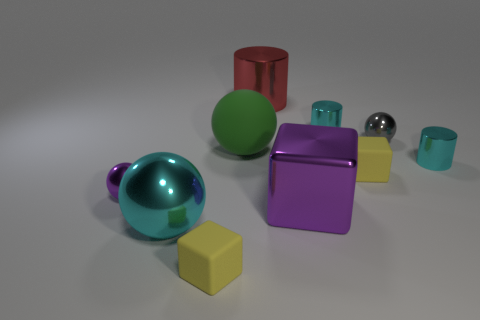Subtract 2 spheres. How many spheres are left? 2 Subtract all blue spheres. Subtract all blue cylinders. How many spheres are left? 4 Subtract all cylinders. How many objects are left? 7 Subtract 0 brown blocks. How many objects are left? 10 Subtract all small blue objects. Subtract all large purple shiny objects. How many objects are left? 9 Add 3 metal objects. How many metal objects are left? 10 Add 3 metal cylinders. How many metal cylinders exist? 6 